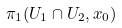<formula> <loc_0><loc_0><loc_500><loc_500>\pi _ { 1 } ( U _ { 1 } \cap U _ { 2 } , x _ { 0 } )</formula> 